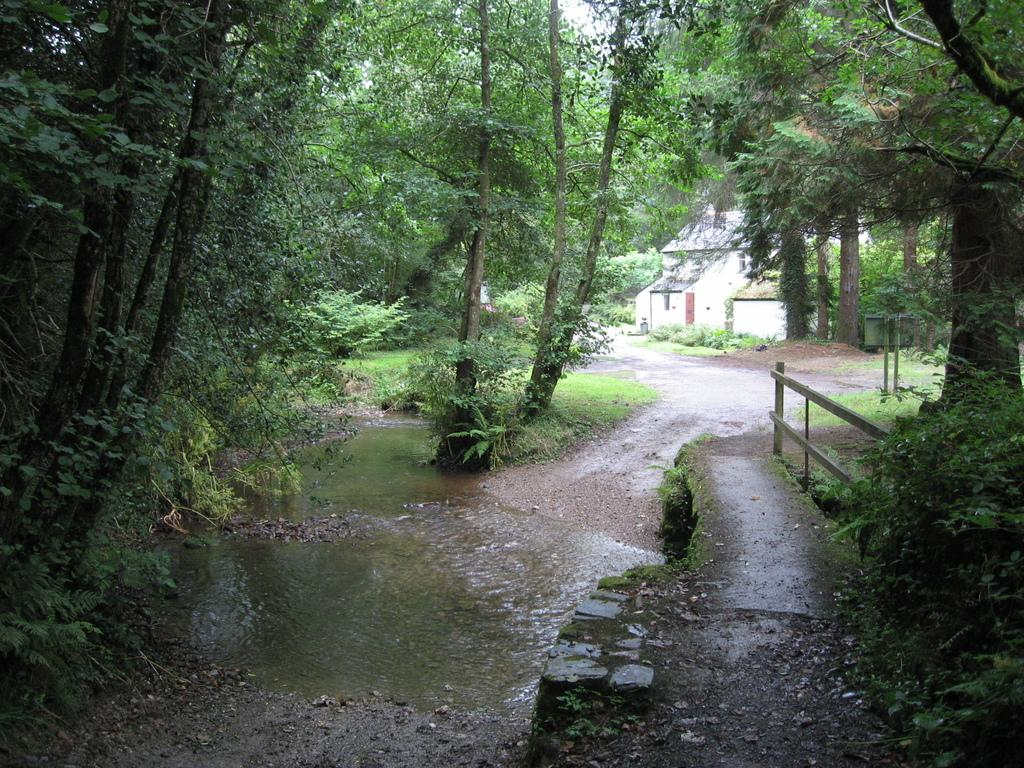What can be seen in the image that is not solid? There is water visible in the image. What type of vegetation is on the left side of the image? There are trees on the left side of the image. What type of vegetation is on the right side of the image? There are trees on the right side of the image. What can be seen in the background of the image? There is a road and a house in the background of the image. What type of dirt is being discussed by the committee in the image? There is no committee or dirt present in the image. What type of parent is shown interacting with the trees in the image? There is no parent present in the image; only trees, water, and a road can be seen. 